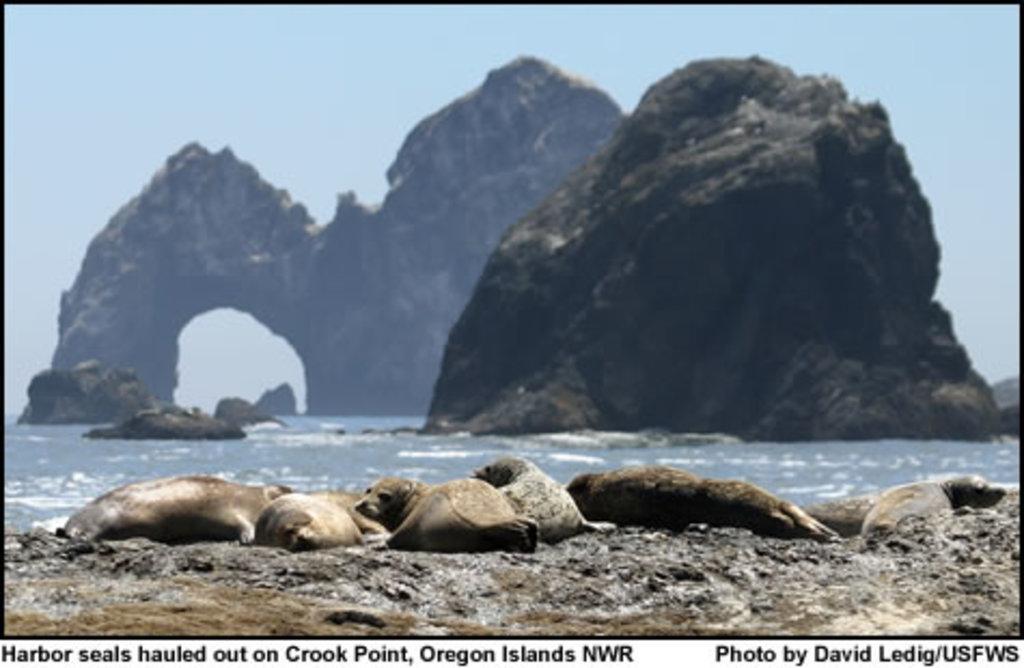Please provide a concise description of this image. This is a poster. In this image there are mountains and in the foreground there are seals. At the top there is sky. At the bottom there is water. 